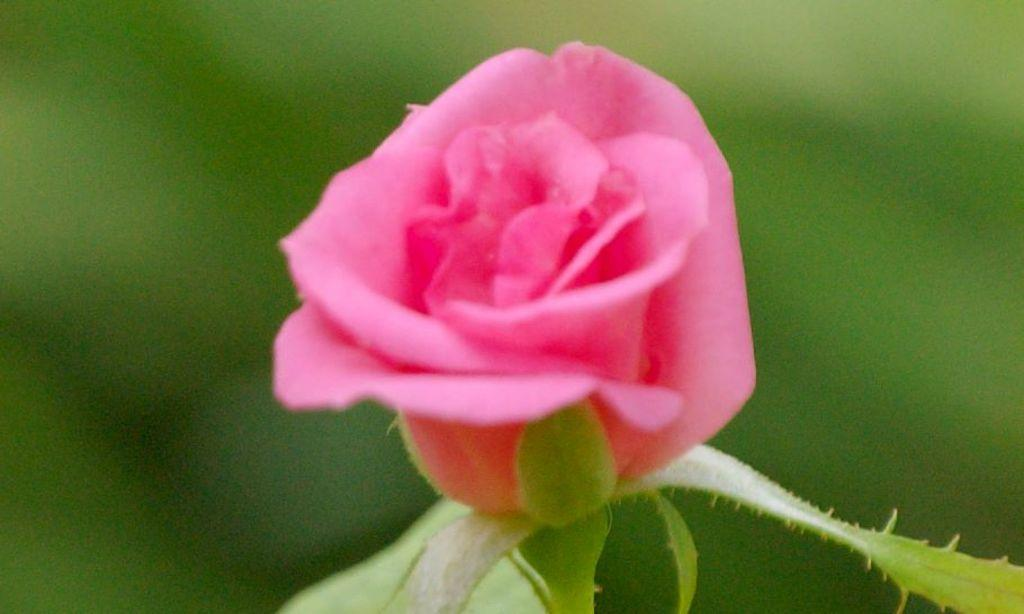What type of flower is in the image? There is a rose flower in the image. What other parts of the rose can be seen in the image? The rose flower has leaves. What can be seen in the distance behind the rose? There are trees in the background of the image. How would you describe the appearance of the background? The background is blurry. What type of humor is being expressed in the image? There is no humor present in the image; it is a photograph of a rose flower with leaves and a blurry background. 